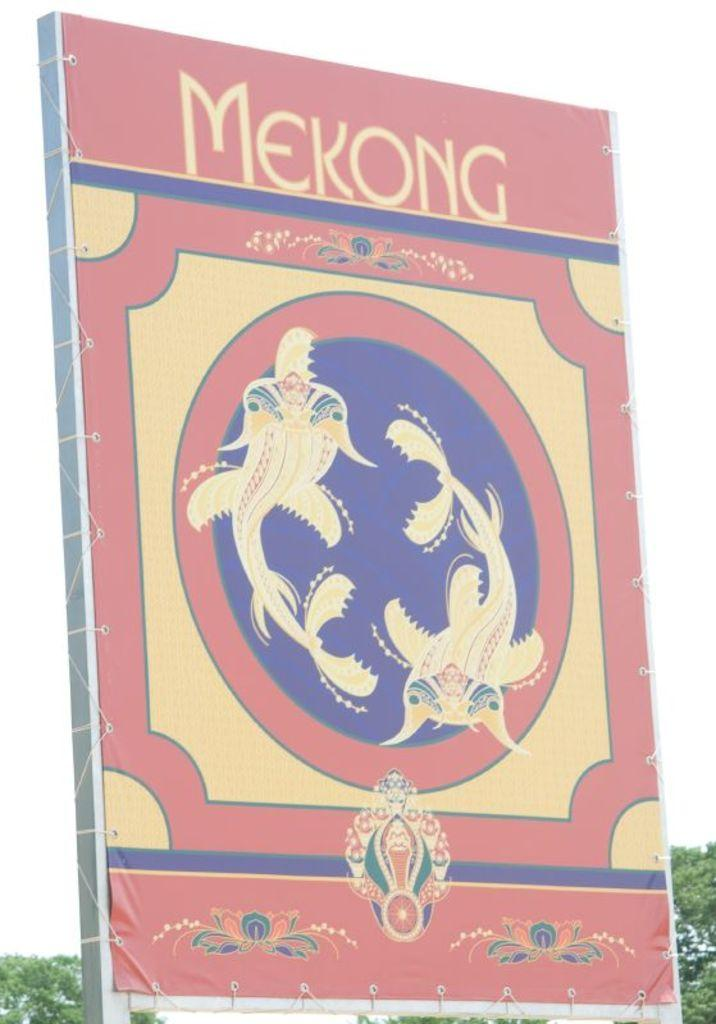<image>
Summarize the visual content of the image. A Chinese poster with Gold Fish and MEKONG designed on the front of it. 